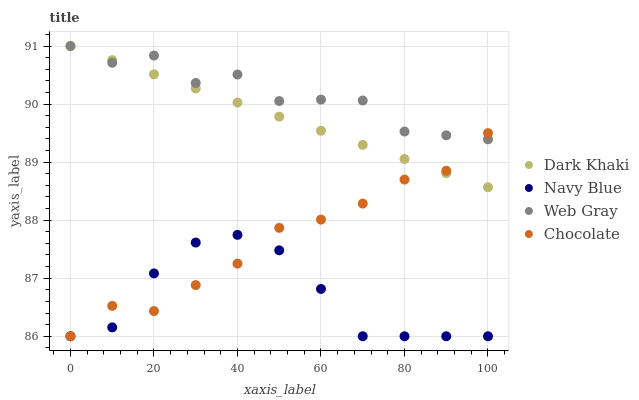Does Navy Blue have the minimum area under the curve?
Answer yes or no. Yes. Does Web Gray have the maximum area under the curve?
Answer yes or no. Yes. Does Web Gray have the minimum area under the curve?
Answer yes or no. No. Does Navy Blue have the maximum area under the curve?
Answer yes or no. No. Is Dark Khaki the smoothest?
Answer yes or no. Yes. Is Web Gray the roughest?
Answer yes or no. Yes. Is Navy Blue the smoothest?
Answer yes or no. No. Is Navy Blue the roughest?
Answer yes or no. No. Does Navy Blue have the lowest value?
Answer yes or no. Yes. Does Web Gray have the lowest value?
Answer yes or no. No. Does Web Gray have the highest value?
Answer yes or no. Yes. Does Navy Blue have the highest value?
Answer yes or no. No. Is Navy Blue less than Web Gray?
Answer yes or no. Yes. Is Web Gray greater than Navy Blue?
Answer yes or no. Yes. Does Chocolate intersect Dark Khaki?
Answer yes or no. Yes. Is Chocolate less than Dark Khaki?
Answer yes or no. No. Is Chocolate greater than Dark Khaki?
Answer yes or no. No. Does Navy Blue intersect Web Gray?
Answer yes or no. No. 